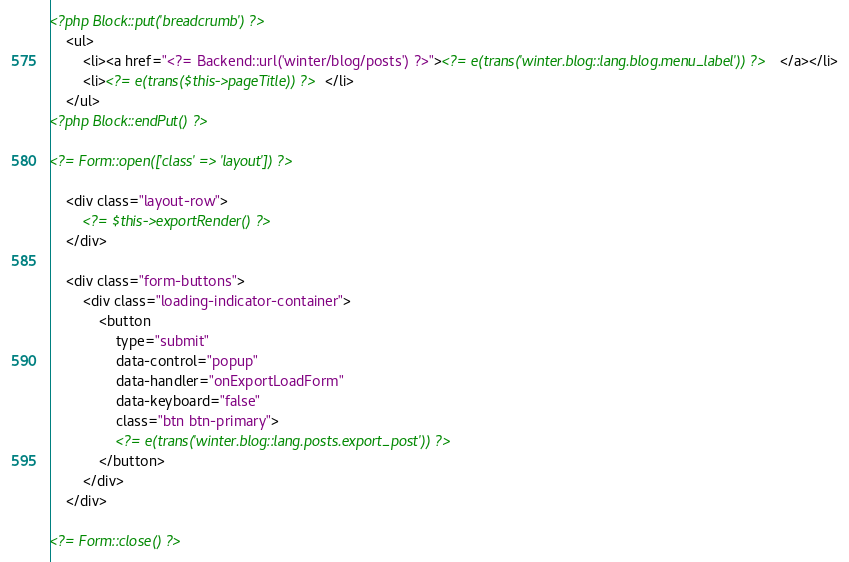<code> <loc_0><loc_0><loc_500><loc_500><_HTML_><?php Block::put('breadcrumb') ?>
    <ul>
        <li><a href="<?= Backend::url('winter/blog/posts') ?>"><?= e(trans('winter.blog::lang.blog.menu_label')) ?></a></li>
        <li><?= e(trans($this->pageTitle)) ?></li>
    </ul>
<?php Block::endPut() ?>

<?= Form::open(['class' => 'layout']) ?>

    <div class="layout-row">
        <?= $this->exportRender() ?>
    </div>

    <div class="form-buttons">
        <div class="loading-indicator-container">
            <button
                type="submit"
                data-control="popup"
                data-handler="onExportLoadForm"
                data-keyboard="false"
                class="btn btn-primary">
                <?= e(trans('winter.blog::lang.posts.export_post')) ?>
            </button>
        </div>
    </div>

<?= Form::close() ?>
</code> 